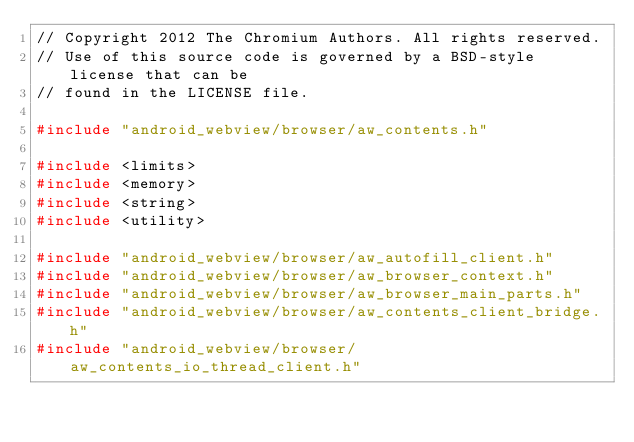<code> <loc_0><loc_0><loc_500><loc_500><_C++_>// Copyright 2012 The Chromium Authors. All rights reserved.
// Use of this source code is governed by a BSD-style license that can be
// found in the LICENSE file.

#include "android_webview/browser/aw_contents.h"

#include <limits>
#include <memory>
#include <string>
#include <utility>

#include "android_webview/browser/aw_autofill_client.h"
#include "android_webview/browser/aw_browser_context.h"
#include "android_webview/browser/aw_browser_main_parts.h"
#include "android_webview/browser/aw_contents_client_bridge.h"
#include "android_webview/browser/aw_contents_io_thread_client.h"</code> 